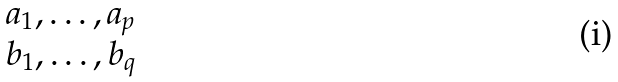<formula> <loc_0><loc_0><loc_500><loc_500>\begin{matrix} a _ { 1 } , \dots , a _ { p } \\ b _ { 1 } , \dots , b _ { q } \end{matrix}</formula> 